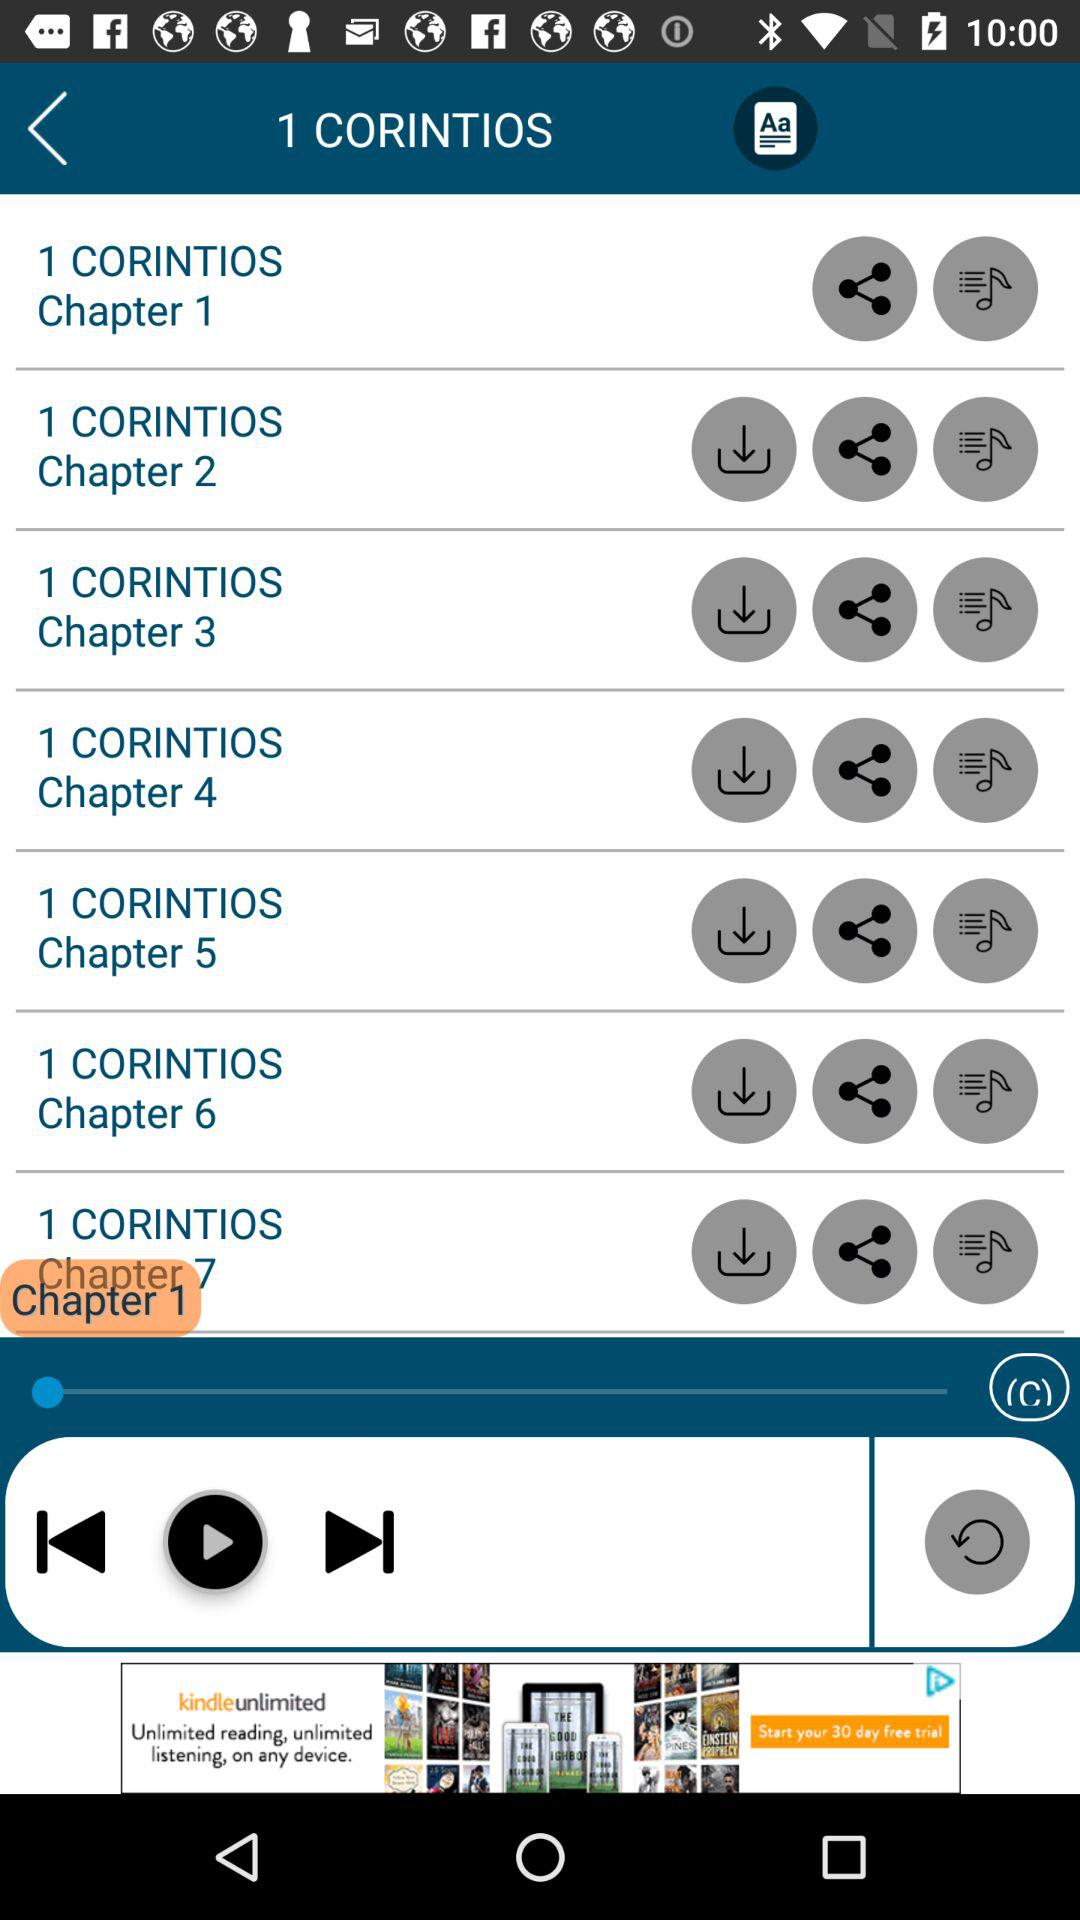How many chapters are in the book of 1 Corinthians?
Answer the question using a single word or phrase. 7 